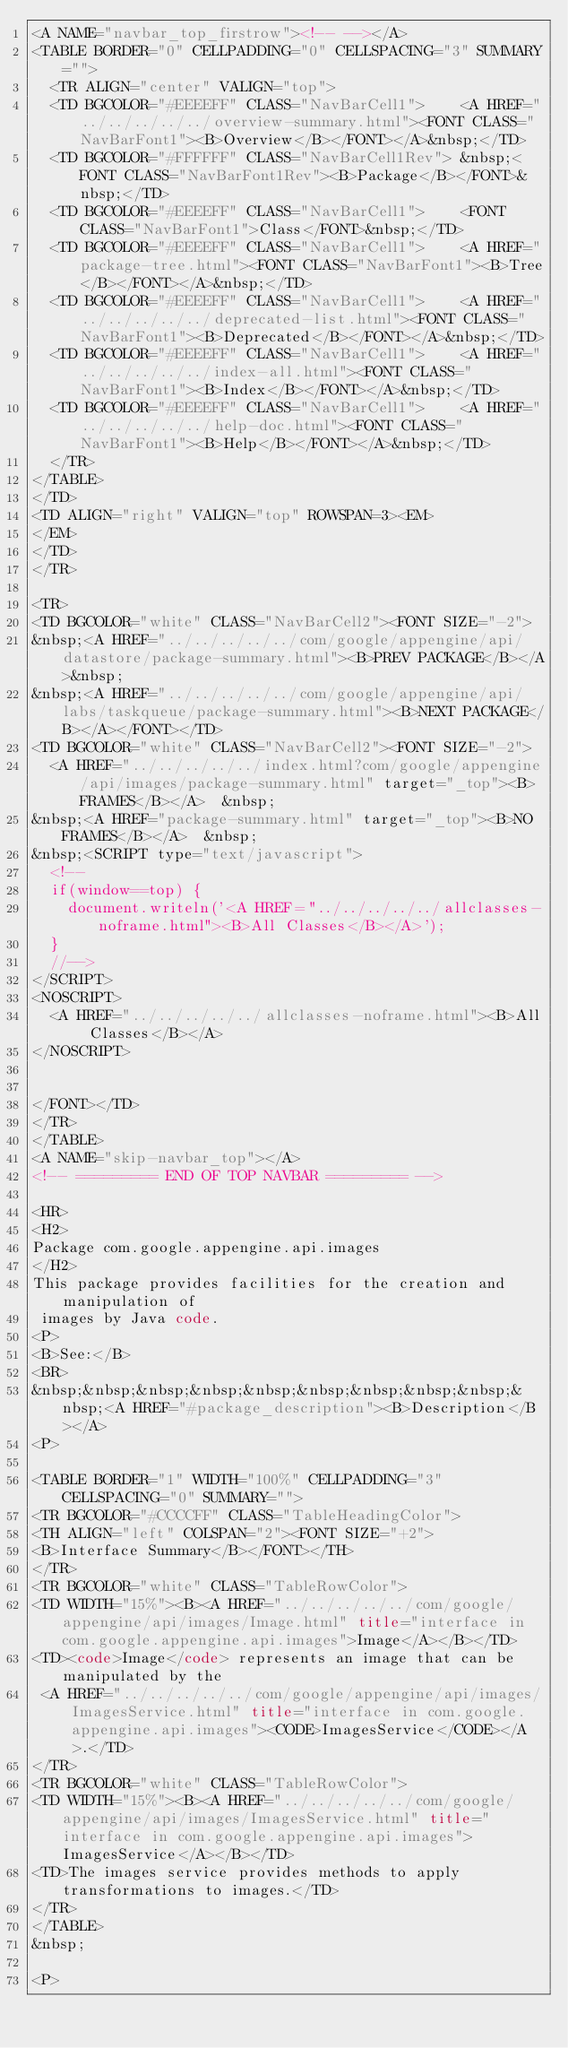<code> <loc_0><loc_0><loc_500><loc_500><_HTML_><A NAME="navbar_top_firstrow"><!-- --></A>
<TABLE BORDER="0" CELLPADDING="0" CELLSPACING="3" SUMMARY="">
  <TR ALIGN="center" VALIGN="top">
  <TD BGCOLOR="#EEEEFF" CLASS="NavBarCell1">    <A HREF="../../../../../overview-summary.html"><FONT CLASS="NavBarFont1"><B>Overview</B></FONT></A>&nbsp;</TD>
  <TD BGCOLOR="#FFFFFF" CLASS="NavBarCell1Rev"> &nbsp;<FONT CLASS="NavBarFont1Rev"><B>Package</B></FONT>&nbsp;</TD>
  <TD BGCOLOR="#EEEEFF" CLASS="NavBarCell1">    <FONT CLASS="NavBarFont1">Class</FONT>&nbsp;</TD>
  <TD BGCOLOR="#EEEEFF" CLASS="NavBarCell1">    <A HREF="package-tree.html"><FONT CLASS="NavBarFont1"><B>Tree</B></FONT></A>&nbsp;</TD>
  <TD BGCOLOR="#EEEEFF" CLASS="NavBarCell1">    <A HREF="../../../../../deprecated-list.html"><FONT CLASS="NavBarFont1"><B>Deprecated</B></FONT></A>&nbsp;</TD>
  <TD BGCOLOR="#EEEEFF" CLASS="NavBarCell1">    <A HREF="../../../../../index-all.html"><FONT CLASS="NavBarFont1"><B>Index</B></FONT></A>&nbsp;</TD>
  <TD BGCOLOR="#EEEEFF" CLASS="NavBarCell1">    <A HREF="../../../../../help-doc.html"><FONT CLASS="NavBarFont1"><B>Help</B></FONT></A>&nbsp;</TD>
  </TR>
</TABLE>
</TD>
<TD ALIGN="right" VALIGN="top" ROWSPAN=3><EM>
</EM>
</TD>
</TR>

<TR>
<TD BGCOLOR="white" CLASS="NavBarCell2"><FONT SIZE="-2">
&nbsp;<A HREF="../../../../../com/google/appengine/api/datastore/package-summary.html"><B>PREV PACKAGE</B></A>&nbsp;
&nbsp;<A HREF="../../../../../com/google/appengine/api/labs/taskqueue/package-summary.html"><B>NEXT PACKAGE</B></A></FONT></TD>
<TD BGCOLOR="white" CLASS="NavBarCell2"><FONT SIZE="-2">
  <A HREF="../../../../../index.html?com/google/appengine/api/images/package-summary.html" target="_top"><B>FRAMES</B></A>  &nbsp;
&nbsp;<A HREF="package-summary.html" target="_top"><B>NO FRAMES</B></A>  &nbsp;
&nbsp;<SCRIPT type="text/javascript">
  <!--
  if(window==top) {
    document.writeln('<A HREF="../../../../../allclasses-noframe.html"><B>All Classes</B></A>');
  }
  //-->
</SCRIPT>
<NOSCRIPT>
  <A HREF="../../../../../allclasses-noframe.html"><B>All Classes</B></A>
</NOSCRIPT>


</FONT></TD>
</TR>
</TABLE>
<A NAME="skip-navbar_top"></A>
<!-- ========= END OF TOP NAVBAR ========= -->

<HR>
<H2>
Package com.google.appengine.api.images
</H2>
This package provides facilities for the creation and manipulation of
 images by Java code.
<P>
<B>See:</B>
<BR>
&nbsp;&nbsp;&nbsp;&nbsp;&nbsp;&nbsp;&nbsp;&nbsp;&nbsp;&nbsp;<A HREF="#package_description"><B>Description</B></A>
<P>

<TABLE BORDER="1" WIDTH="100%" CELLPADDING="3" CELLSPACING="0" SUMMARY="">
<TR BGCOLOR="#CCCCFF" CLASS="TableHeadingColor">
<TH ALIGN="left" COLSPAN="2"><FONT SIZE="+2">
<B>Interface Summary</B></FONT></TH>
</TR>
<TR BGCOLOR="white" CLASS="TableRowColor">
<TD WIDTH="15%"><B><A HREF="../../../../../com/google/appengine/api/images/Image.html" title="interface in com.google.appengine.api.images">Image</A></B></TD>
<TD><code>Image</code> represents an image that can be manipulated by the
 <A HREF="../../../../../com/google/appengine/api/images/ImagesService.html" title="interface in com.google.appengine.api.images"><CODE>ImagesService</CODE></A>.</TD>
</TR>
<TR BGCOLOR="white" CLASS="TableRowColor">
<TD WIDTH="15%"><B><A HREF="../../../../../com/google/appengine/api/images/ImagesService.html" title="interface in com.google.appengine.api.images">ImagesService</A></B></TD>
<TD>The images service provides methods to apply transformations to images.</TD>
</TR>
</TABLE>
&nbsp;

<P>
</code> 